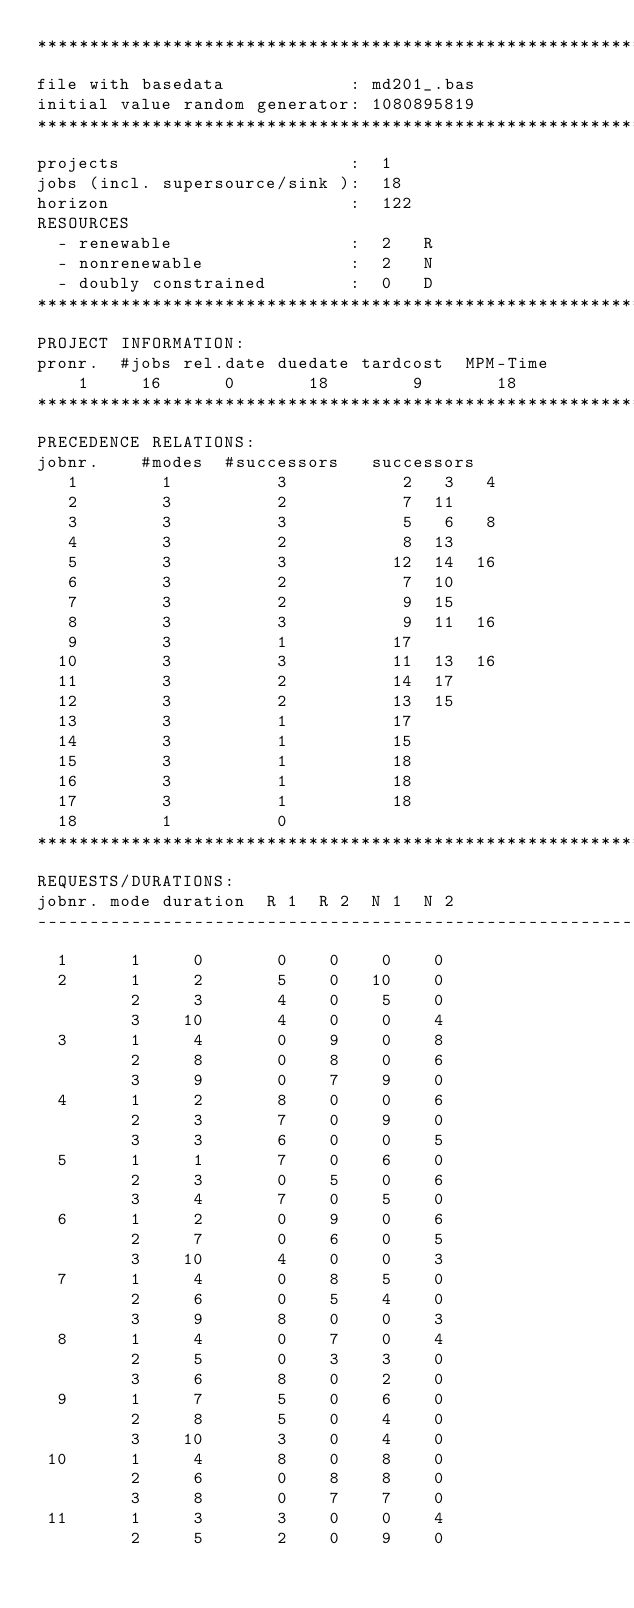<code> <loc_0><loc_0><loc_500><loc_500><_ObjectiveC_>************************************************************************
file with basedata            : md201_.bas
initial value random generator: 1080895819
************************************************************************
projects                      :  1
jobs (incl. supersource/sink ):  18
horizon                       :  122
RESOURCES
  - renewable                 :  2   R
  - nonrenewable              :  2   N
  - doubly constrained        :  0   D
************************************************************************
PROJECT INFORMATION:
pronr.  #jobs rel.date duedate tardcost  MPM-Time
    1     16      0       18        9       18
************************************************************************
PRECEDENCE RELATIONS:
jobnr.    #modes  #successors   successors
   1        1          3           2   3   4
   2        3          2           7  11
   3        3          3           5   6   8
   4        3          2           8  13
   5        3          3          12  14  16
   6        3          2           7  10
   7        3          2           9  15
   8        3          3           9  11  16
   9        3          1          17
  10        3          3          11  13  16
  11        3          2          14  17
  12        3          2          13  15
  13        3          1          17
  14        3          1          15
  15        3          1          18
  16        3          1          18
  17        3          1          18
  18        1          0        
************************************************************************
REQUESTS/DURATIONS:
jobnr. mode duration  R 1  R 2  N 1  N 2
------------------------------------------------------------------------
  1      1     0       0    0    0    0
  2      1     2       5    0   10    0
         2     3       4    0    5    0
         3    10       4    0    0    4
  3      1     4       0    9    0    8
         2     8       0    8    0    6
         3     9       0    7    9    0
  4      1     2       8    0    0    6
         2     3       7    0    9    0
         3     3       6    0    0    5
  5      1     1       7    0    6    0
         2     3       0    5    0    6
         3     4       7    0    5    0
  6      1     2       0    9    0    6
         2     7       0    6    0    5
         3    10       4    0    0    3
  7      1     4       0    8    5    0
         2     6       0    5    4    0
         3     9       8    0    0    3
  8      1     4       0    7    0    4
         2     5       0    3    3    0
         3     6       8    0    2    0
  9      1     7       5    0    6    0
         2     8       5    0    4    0
         3    10       3    0    4    0
 10      1     4       8    0    8    0
         2     6       0    8    8    0
         3     8       0    7    7    0
 11      1     3       3    0    0    4
         2     5       2    0    9    0</code> 